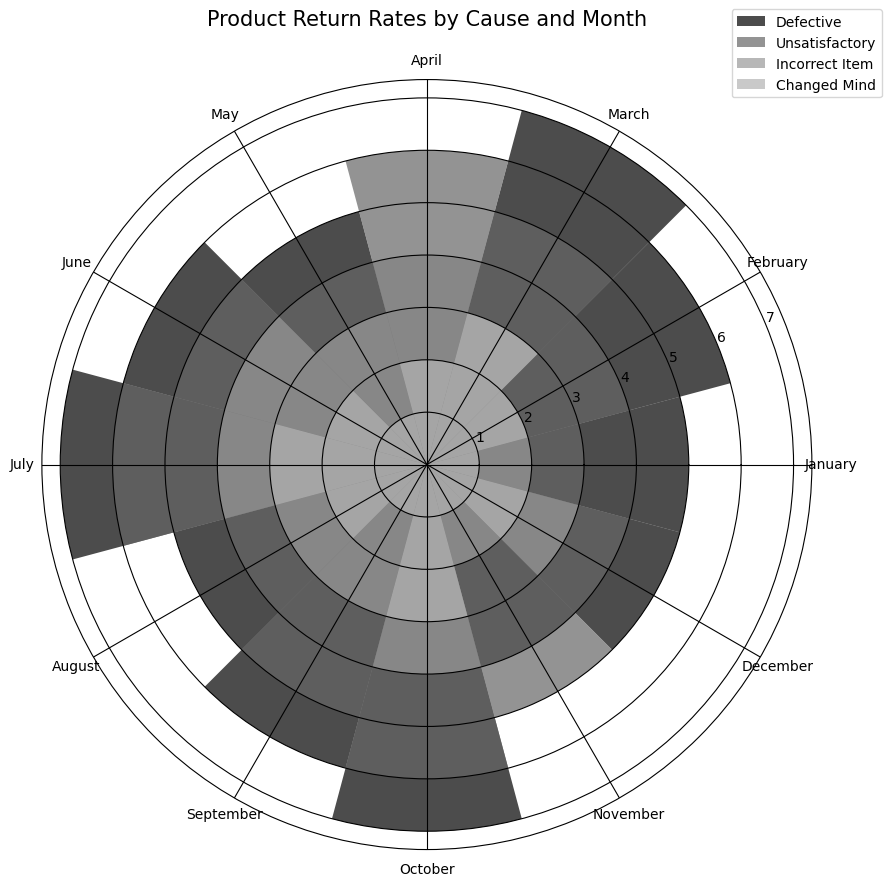What month has the highest return rate for 'Defective' products? To find the month with the highest return rate for 'Defective' products, look for the longest bar in the 'Defective' section.
Answer: July, October Which cause has the highest overall return rate for 'April'? Check the heights of the bars corresponding to 'April' and identify the tallest one.
Answer: Unsatisfactory Compare the return rates of 'Incorrect Item' and 'Changed Mind' for 'March'. Which one is higher and by how much? Look at the bar heights for 'Incorrect Item' and 'Changed Mind' in March. Subtract the smaller height from the larger one to find the difference.
Answer: Incorrect Item, by 0 Which cause shows the least variation in return rates across all months? Observe the consistency of bar heights for each cause across different months. The cause with the most uniform bar heights has the least variation.
Answer: Incorrect Item Sum up the return rates of all causes combined for 'June'. Add up the bar heights corresponding to all causes in June.
Answer: 17 When comparing 'November' to 'December', which month has higher return rates for 'Changed Mind' and by how much? Check the heights of the 'Changed Mind' bars for November and December. Subtract the smaller one from the larger one.
Answer: December, by 1 For which month is the sum of return rates for 'Defective' and 'Unsatisfactory' equal to the sum of return rates for 'Incorrect Item' and 'Changed Mind'? Calculate the sums for each month and compare them. Identify the month where the two sums are equal.
Answer: January What is the average return rate for 'Unsatisfactory' causes across all months? Sum the return rates for 'Unsatisfactory' across all months and divide by the number of months.
Answer: 4.75 Compare the return rates of 'Defective' products for 'February' and 'September'. Which month has higher rates and by how much? Check the heights of the bars for 'Defective' in February and September. Subtract the smaller one from the larger one.
Answer: September, by 0 Identify the month with the lowest return rate for 'Incorrect Item'. Observe the bar heights for 'Incorrect Item' across all months. The shortest bar indicates the month with the lowest return rate.
Answer: January, November Calculate the difference in total return rates between 'May' and 'August'. Which month has lower total return rates and what is the difference? Sum the return rates for all causes in May and August separately, then subtract the smaller sum from the larger one.
Answer: May, by 2 